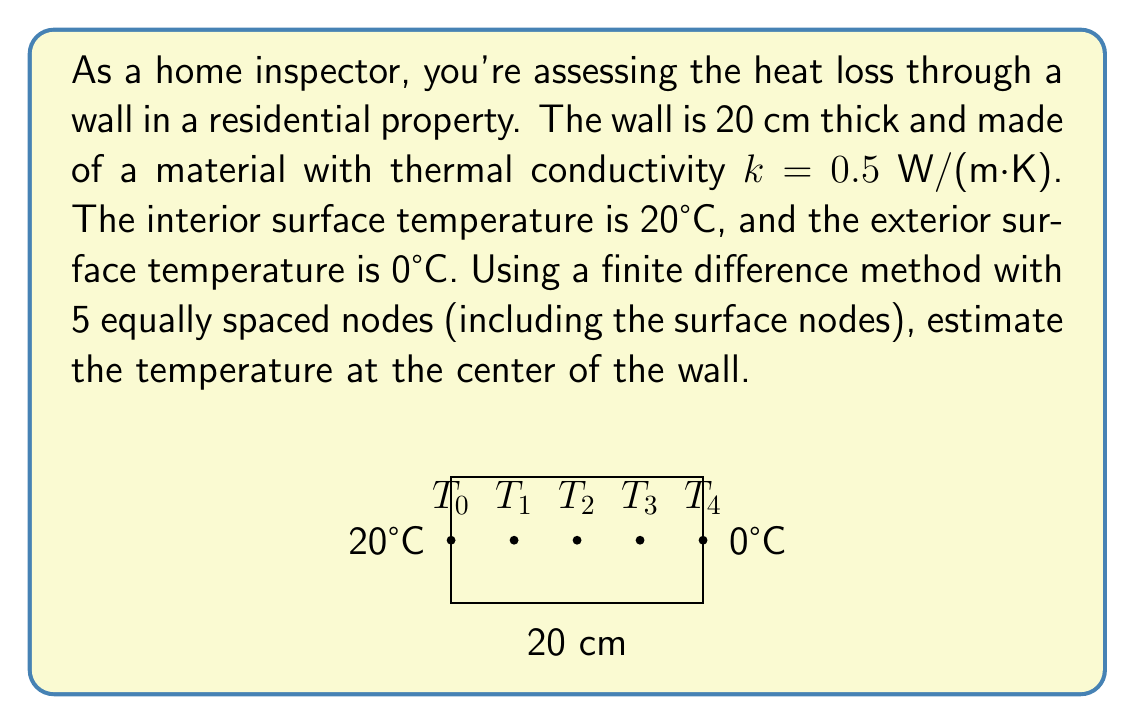Help me with this question. To solve this problem using the finite difference method, we'll follow these steps:

1) First, let's set up our nodes. With 5 nodes, we have:
   $T_0$ (interior surface), $T_1$, $T_2$ (center), $T_3$, and $T_4$ (exterior surface)

2) The spacing between nodes, $\Delta x$, is:
   $$\Delta x = \frac{20 \text{ cm}}{4} = 5 \text{ cm} = 0.05 \text{ m}$$

3) For steady-state heat conduction in a wall with no heat generation, the finite difference equation is:
   $$\frac{T_{i-1} - 2T_i + T_{i+1}}{(\Delta x)^2} = 0$$

4) We know $T_0 = 20°C$ and $T_4 = 0°C$. We need to set up equations for $T_1$, $T_2$, and $T_3$:

   For $T_1$: $20 - 2T_1 + T_2 = 0$
   For $T_2$: $T_1 - 2T_2 + T_3 = 0$
   For $T_3$: $T_2 - 2T_3 + 0 = 0$

5) From the equation for $T_3$: $T_2 = 2T_3$

6) Substituting this into the equation for $T_2$:
   $T_1 - 2(2T_3) + T_3 = 0$
   $T_1 - 3T_3 = 0$
   $T_1 = 3T_3$

7) Now, substituting both of these into the equation for $T_1$:
   $20 - 2(3T_3) + 2T_3 = 0$
   $20 - 4T_3 = 0$
   $T_3 = 5°C$

8) Working backwards:
   $T_2 = 2T_3 = 2(5) = 10°C$
   $T_1 = 3T_3 = 3(5) = 15°C$

Therefore, the temperature at the center of the wall ($T_2$) is 10°C.
Answer: 10°C 